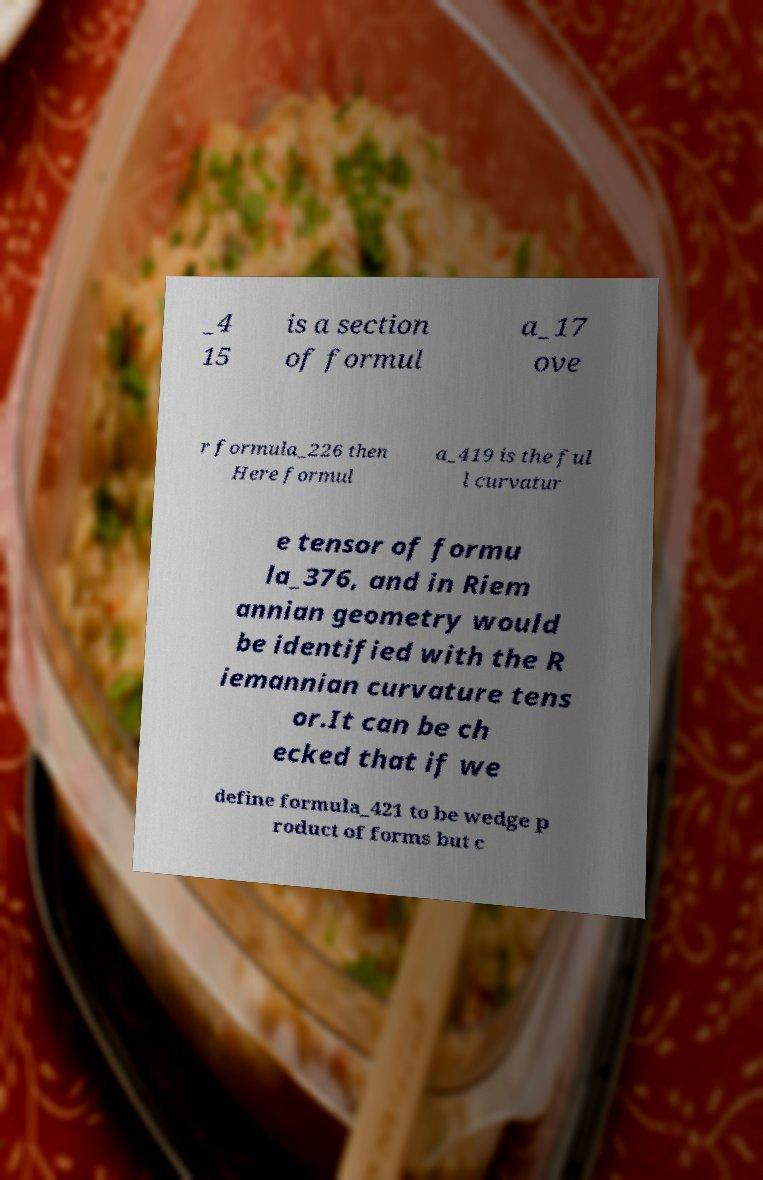Could you assist in decoding the text presented in this image and type it out clearly? _4 15 is a section of formul a_17 ove r formula_226 then Here formul a_419 is the ful l curvatur e tensor of formu la_376, and in Riem annian geometry would be identified with the R iemannian curvature tens or.It can be ch ecked that if we define formula_421 to be wedge p roduct of forms but c 